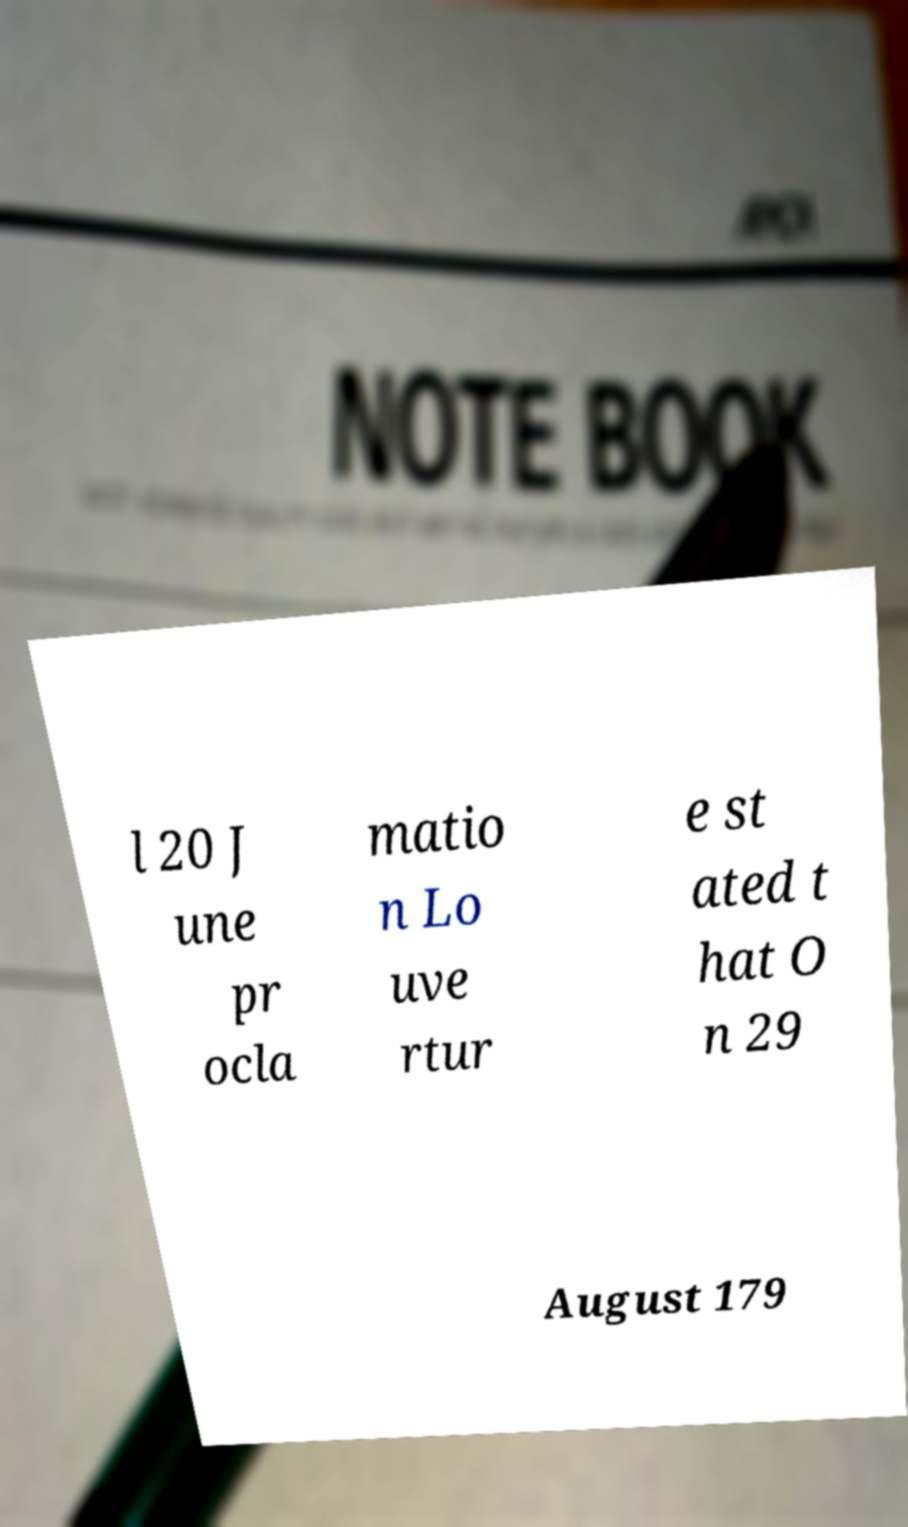Could you extract and type out the text from this image? l 20 J une pr ocla matio n Lo uve rtur e st ated t hat O n 29 August 179 